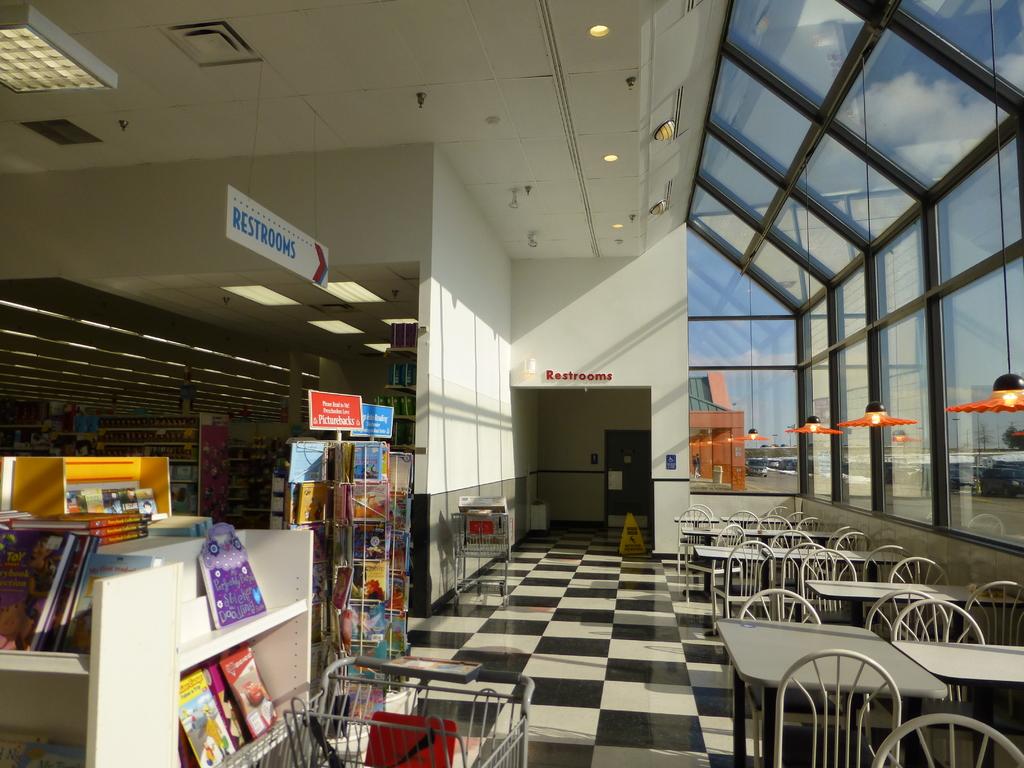What is dead ahead?
Provide a short and direct response. Restrooms. What is the arrow sign pointing to?
Keep it short and to the point. Restrooms. 